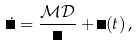Convert formula to latex. <formula><loc_0><loc_0><loc_500><loc_500>\dot { \Omega } = \frac { { \mathcal { M } } { \mathcal { D } } } { \Omega } + \Xi ( t ) \, ,</formula> 